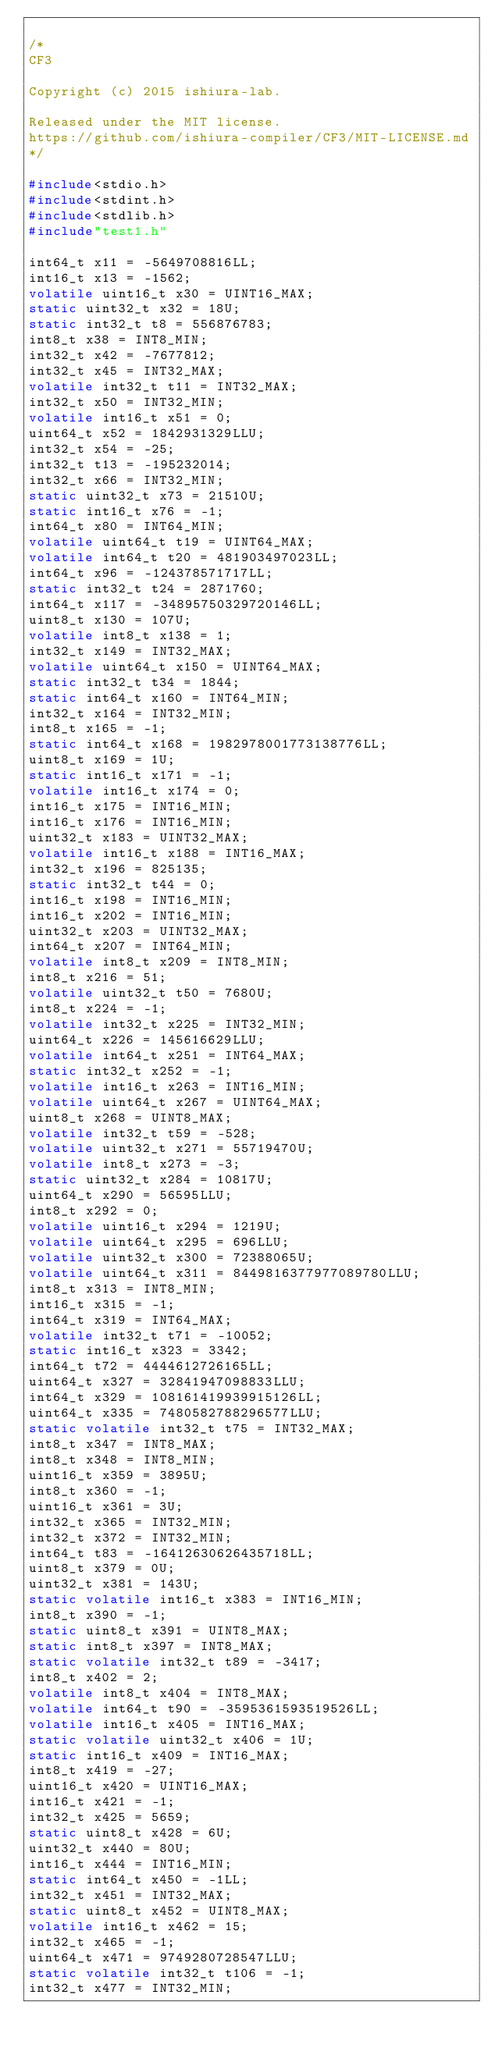<code> <loc_0><loc_0><loc_500><loc_500><_C_>
/*
CF3

Copyright (c) 2015 ishiura-lab.

Released under the MIT license.  
https://github.com/ishiura-compiler/CF3/MIT-LICENSE.md
*/

#include<stdio.h>
#include<stdint.h>
#include<stdlib.h>
#include"test1.h"

int64_t x11 = -5649708816LL;
int16_t x13 = -1562;
volatile uint16_t x30 = UINT16_MAX;
static uint32_t x32 = 18U;
static int32_t t8 = 556876783;
int8_t x38 = INT8_MIN;
int32_t x42 = -7677812;
int32_t x45 = INT32_MAX;
volatile int32_t t11 = INT32_MAX;
int32_t x50 = INT32_MIN;
volatile int16_t x51 = 0;
uint64_t x52 = 1842931329LLU;
int32_t x54 = -25;
int32_t t13 = -195232014;
int32_t x66 = INT32_MIN;
static uint32_t x73 = 21510U;
static int16_t x76 = -1;
int64_t x80 = INT64_MIN;
volatile uint64_t t19 = UINT64_MAX;
volatile int64_t t20 = 481903497023LL;
int64_t x96 = -124378571717LL;
static int32_t t24 = 2871760;
int64_t x117 = -34895750329720146LL;
uint8_t x130 = 107U;
volatile int8_t x138 = 1;
int32_t x149 = INT32_MAX;
volatile uint64_t x150 = UINT64_MAX;
static int32_t t34 = 1844;
static int64_t x160 = INT64_MIN;
int32_t x164 = INT32_MIN;
int8_t x165 = -1;
static int64_t x168 = 1982978001773138776LL;
uint8_t x169 = 1U;
static int16_t x171 = -1;
volatile int16_t x174 = 0;
int16_t x175 = INT16_MIN;
int16_t x176 = INT16_MIN;
uint32_t x183 = UINT32_MAX;
volatile int16_t x188 = INT16_MAX;
int32_t x196 = 825135;
static int32_t t44 = 0;
int16_t x198 = INT16_MIN;
int16_t x202 = INT16_MIN;
uint32_t x203 = UINT32_MAX;
int64_t x207 = INT64_MIN;
volatile int8_t x209 = INT8_MIN;
int8_t x216 = 51;
volatile uint32_t t50 = 7680U;
int8_t x224 = -1;
volatile int32_t x225 = INT32_MIN;
uint64_t x226 = 145616629LLU;
volatile int64_t x251 = INT64_MAX;
static int32_t x252 = -1;
volatile int16_t x263 = INT16_MIN;
volatile uint64_t x267 = UINT64_MAX;
uint8_t x268 = UINT8_MAX;
volatile int32_t t59 = -528;
volatile uint32_t x271 = 55719470U;
volatile int8_t x273 = -3;
static uint32_t x284 = 10817U;
uint64_t x290 = 56595LLU;
int8_t x292 = 0;
volatile uint16_t x294 = 1219U;
volatile uint64_t x295 = 696LLU;
volatile uint32_t x300 = 72388065U;
volatile uint64_t x311 = 8449816377977089780LLU;
int8_t x313 = INT8_MIN;
int16_t x315 = -1;
int64_t x319 = INT64_MAX;
volatile int32_t t71 = -10052;
static int16_t x323 = 3342;
int64_t t72 = 4444612726165LL;
uint64_t x327 = 32841947098833LLU;
int64_t x329 = 108161419939915126LL;
uint64_t x335 = 7480582788296577LLU;
static volatile int32_t t75 = INT32_MAX;
int8_t x347 = INT8_MAX;
int8_t x348 = INT8_MIN;
uint16_t x359 = 3895U;
int8_t x360 = -1;
uint16_t x361 = 3U;
int32_t x365 = INT32_MIN;
int32_t x372 = INT32_MIN;
int64_t t83 = -16412630626435718LL;
uint8_t x379 = 0U;
uint32_t x381 = 143U;
static volatile int16_t x383 = INT16_MIN;
int8_t x390 = -1;
static uint8_t x391 = UINT8_MAX;
static int8_t x397 = INT8_MAX;
static volatile int32_t t89 = -3417;
int8_t x402 = 2;
volatile int8_t x404 = INT8_MAX;
volatile int64_t t90 = -3595361593519526LL;
volatile int16_t x405 = INT16_MAX;
static volatile uint32_t x406 = 1U;
static int16_t x409 = INT16_MAX;
int8_t x419 = -27;
uint16_t x420 = UINT16_MAX;
int16_t x421 = -1;
int32_t x425 = 5659;
static uint8_t x428 = 6U;
uint32_t x440 = 80U;
int16_t x444 = INT16_MIN;
static int64_t x450 = -1LL;
int32_t x451 = INT32_MAX;
static uint8_t x452 = UINT8_MAX;
volatile int16_t x462 = 15;
int32_t x465 = -1;
uint64_t x471 = 9749280728547LLU;
static volatile int32_t t106 = -1;
int32_t x477 = INT32_MIN;</code> 